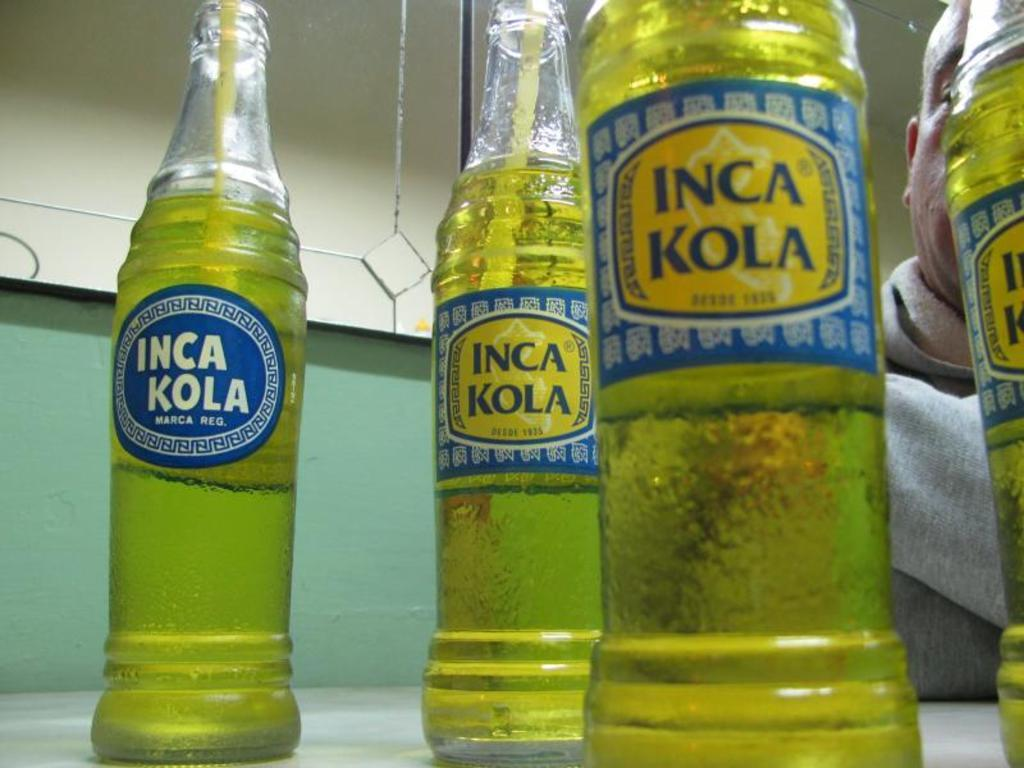<image>
Give a short and clear explanation of the subsequent image. Several bottles of Inca Kola sitting on a table with a person sitting behind them. 